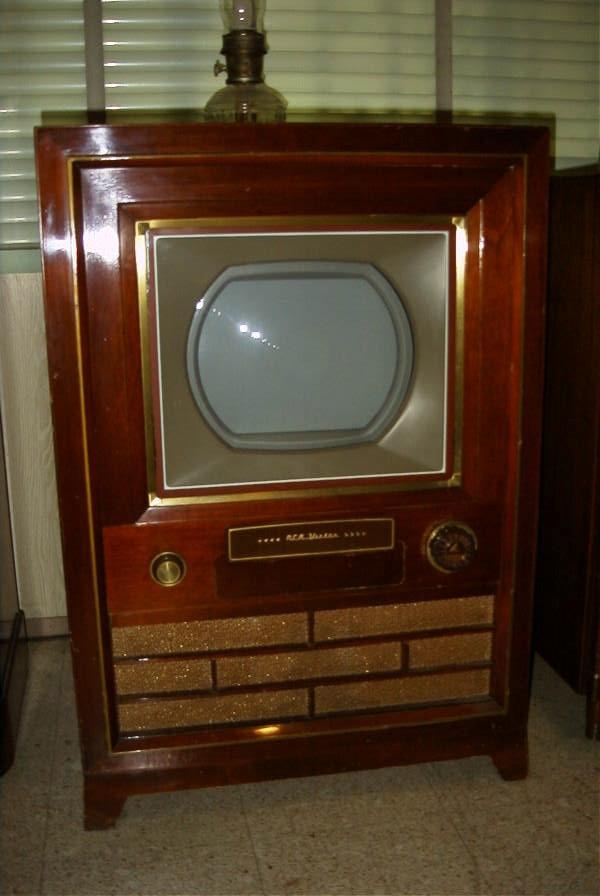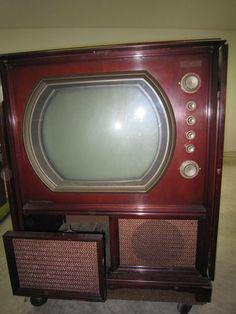The first image is the image on the left, the second image is the image on the right. Assess this claim about the two images: "In at lease on image, there is a oval shaped tv screen held by wooden tv case that has three rows of brick like rectangles.". Correct or not? Answer yes or no. Yes. The first image is the image on the left, the second image is the image on the right. Analyze the images presented: Is the assertion "The speaker under one of the television monitors shows a horizontal brick-like pattern." valid? Answer yes or no. Yes. 